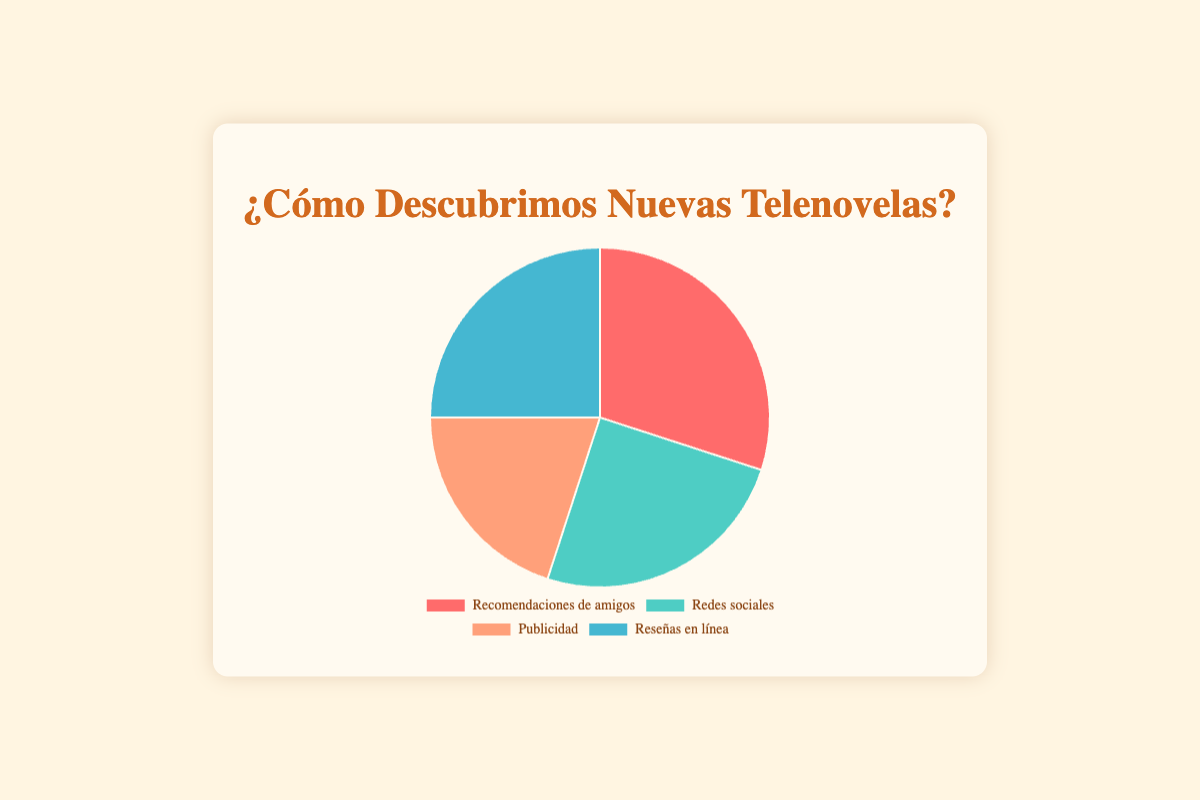Which source is represented by the red segment? The red segment in the pie chart represents "Recommendations from friends". You can identify this by matching the color coding with the legend.
Answer: Recommendations from friends Which two sources have the same percentage? By looking at the percentages shown in the chart, "Social media" and "Online reviews" both have 25%.
Answer: Social media & Online reviews What is the total percentage of sources other than recommendations from friends? The sources other than "Recommendations from friends" are Social media (25%), Advertisements (20%), and Online reviews (25%). Sum these percentages: 25 + 20 + 25 = 70%
Answer: 70% Which source has the lowest percentage, and what is it? The lowest percentage can be found by comparing all the segments. "Advertisements" has the lowest percentage at 20%.
Answer: Advertisements, 20% What is the percentage difference between the highest and the lowest sources? The highest percentage is for "Recommendations from friends" at 30%. The lowest is "Advertisements" at 20%. The difference is 30 - 20 = 10%.
Answer: 10% How much more percentage do social media and online reviews combined have compared to recommendations from friends? Sum the percentages for social media and online reviews: 25 + 25 = 50%. Compare it to recommendations from friends, which is 30%. The difference is 50 - 30 = 20%.
Answer: 20% What percentage of viewers discovered new telenovelas through digital platforms (social media and online reviews)? Sum the percentages for social media and online reviews: 25 + 25 = 50%.
Answer: 50% Which color represents "Advertisements" in the pie chart? "Advertisements" is represented by the orange segment in the pie chart. You can verify this by matching the color with the legend indicating "Advertisements".
Answer: Orange 